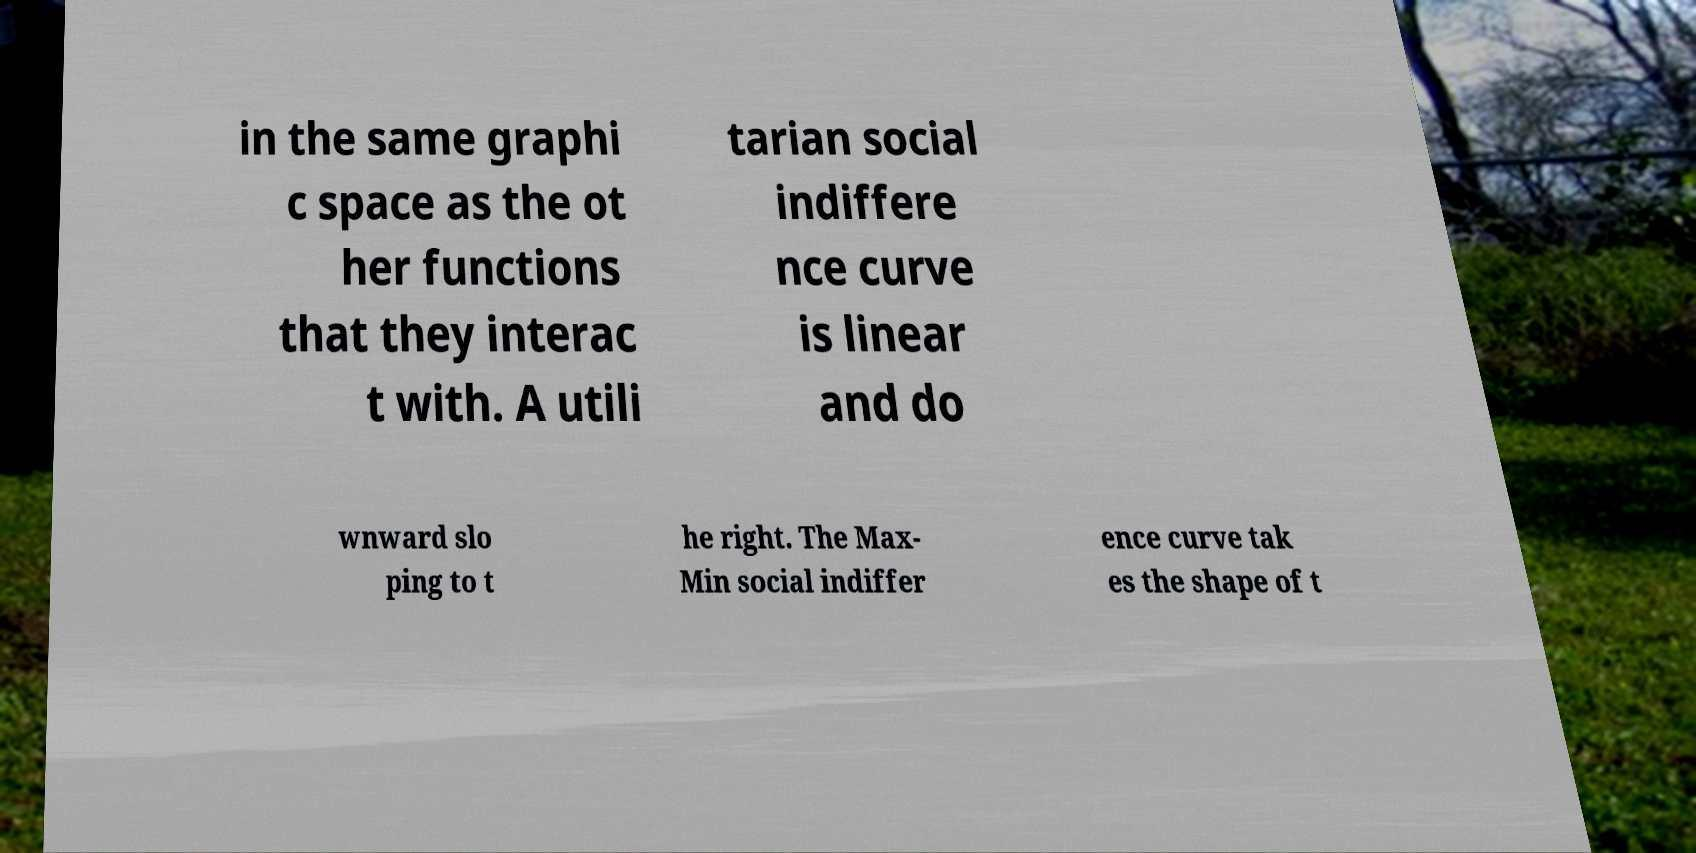There's text embedded in this image that I need extracted. Can you transcribe it verbatim? in the same graphi c space as the ot her functions that they interac t with. A utili tarian social indiffere nce curve is linear and do wnward slo ping to t he right. The Max- Min social indiffer ence curve tak es the shape of t 